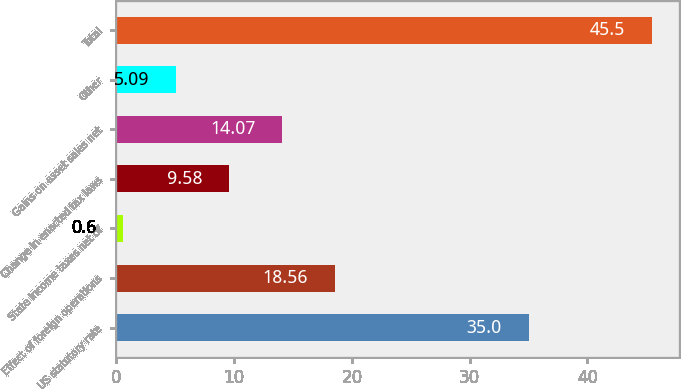<chart> <loc_0><loc_0><loc_500><loc_500><bar_chart><fcel>US statutory rate<fcel>Effect of foreign operations<fcel>State income taxes net of<fcel>Change in enacted tax laws<fcel>Gains on asset sales net<fcel>Other<fcel>Total<nl><fcel>35<fcel>18.56<fcel>0.6<fcel>9.58<fcel>14.07<fcel>5.09<fcel>45.5<nl></chart> 